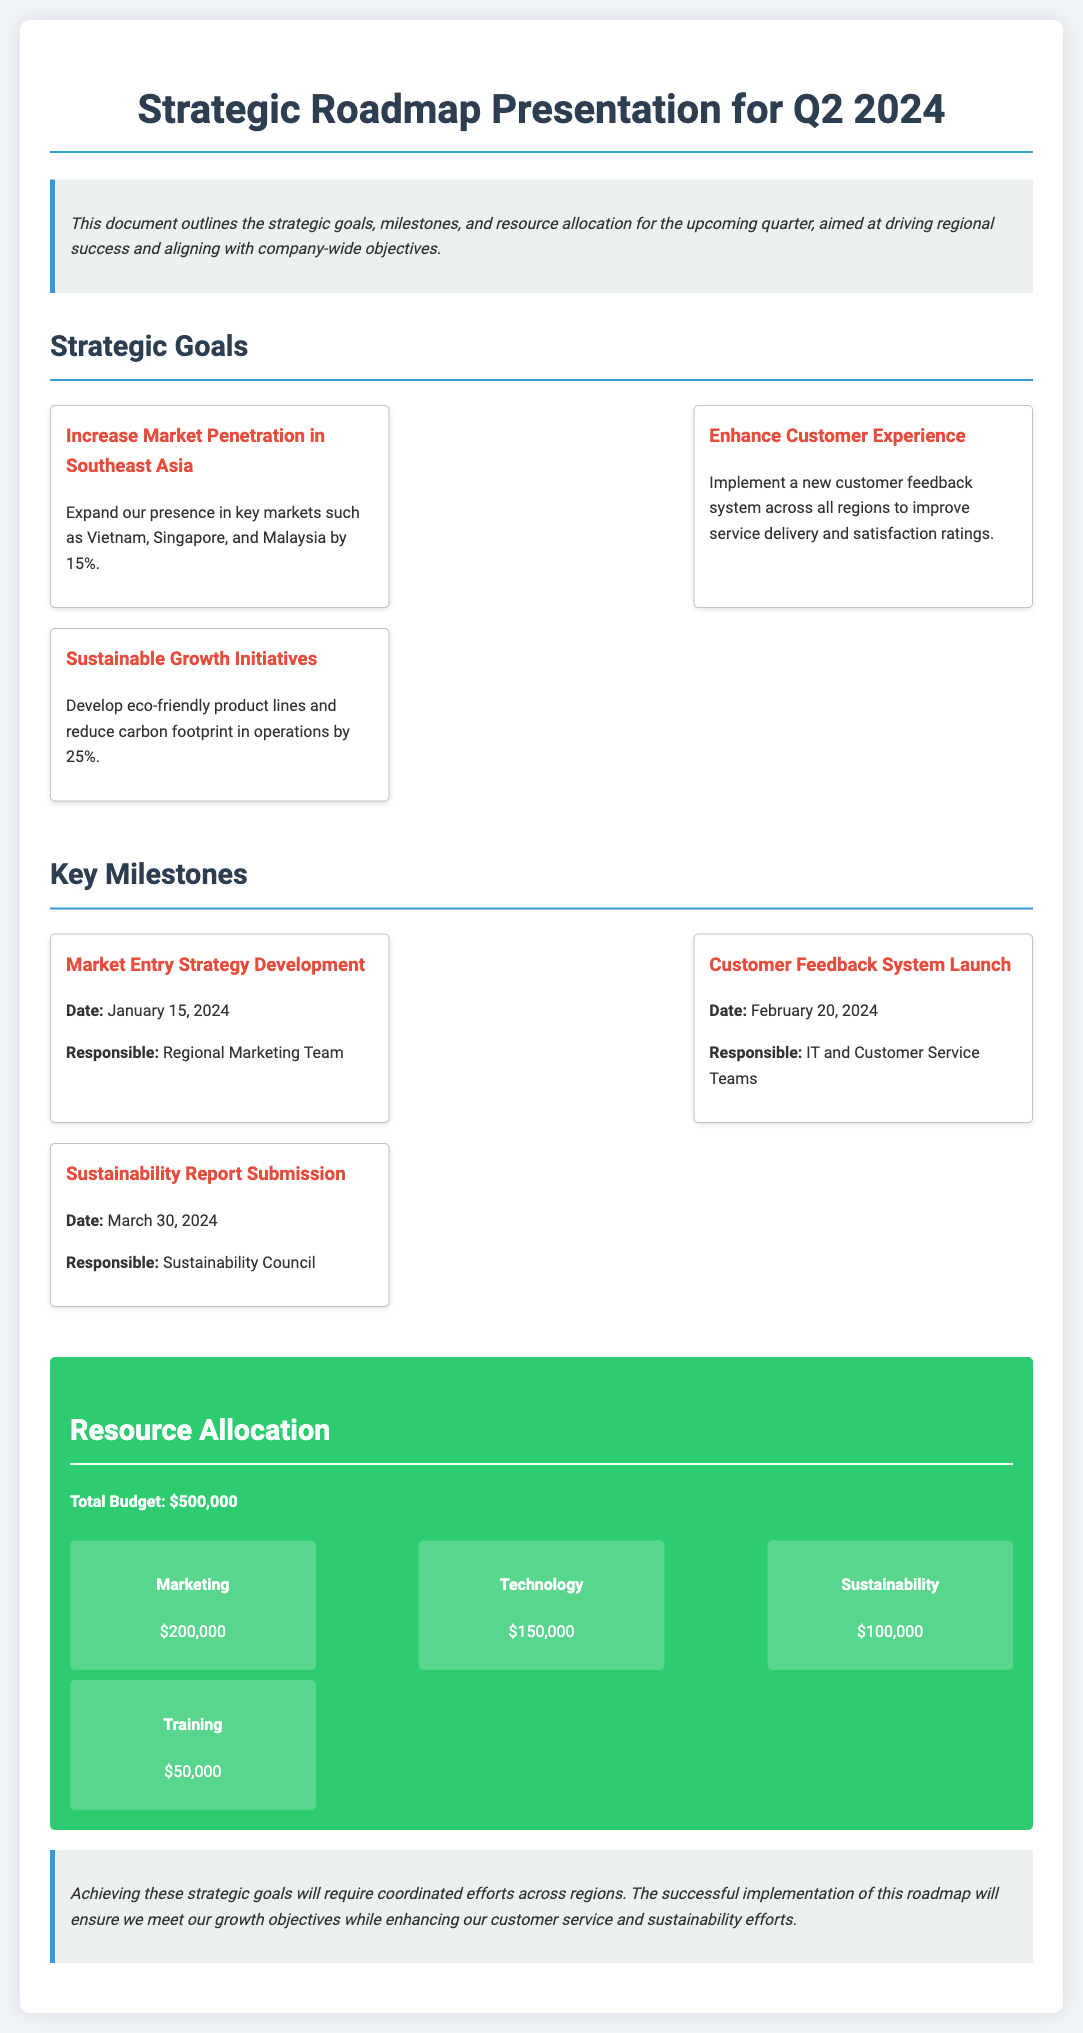What is the title of the document? The title of the document is specified in the header section of the HTML as "Strategic Roadmap Presentation for Q2 2024."
Answer: Strategic Roadmap Presentation for Q2 2024 What is the total budget allocated for Q2 2024? The total budget is mentioned in the resource allocation section of the document.
Answer: $500,000 Which region is targeted for market penetration? The strategic goal specifies the region in focus for market penetration.
Answer: Southeast Asia When is the customer feedback system launch date? The date for the customer feedback system launch is provided in the milestones section of the document.
Answer: February 20, 2024 Who is responsible for the sustainability report submission? The responsible party for the sustainability report submission is identified in the milestones section of the document.
Answer: Sustainability Council What percentage is the goal for increasing market penetration? The percentage goal for increasing market penetration is mentioned under the respective strategic goal.
Answer: 15% How much budget is allocated for Marketing? The budget allocation for Marketing is detailed in the budget breakdown section.
Answer: $200,000 What is the main theme of the document? The document outlines strategic goals, milestones, and resource allocation, indicating the intention to drive regional success.
Answer: Strategic goals and resource allocation What is one of the sustainable growth initiatives mentioned? The document lists specific sustainable growth initiatives under strategic goals.
Answer: Develop eco-friendly product lines 